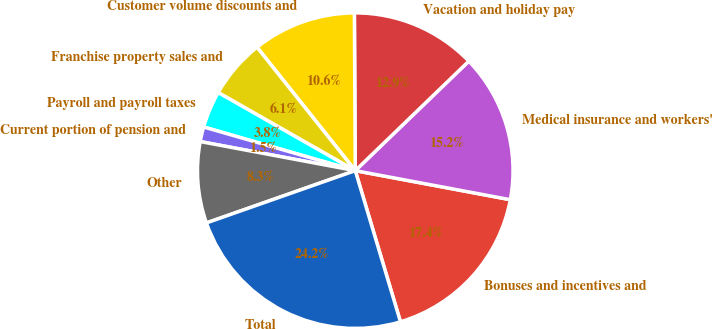Convert chart to OTSL. <chart><loc_0><loc_0><loc_500><loc_500><pie_chart><fcel>Bonuses and incentives and<fcel>Medical insurance and workers'<fcel>Vacation and holiday pay<fcel>Customer volume discounts and<fcel>Franchise property sales and<fcel>Payroll and payroll taxes<fcel>Current portion of pension and<fcel>Other<fcel>Total<nl><fcel>17.43%<fcel>15.16%<fcel>12.88%<fcel>10.61%<fcel>6.06%<fcel>3.78%<fcel>1.51%<fcel>8.33%<fcel>24.25%<nl></chart> 